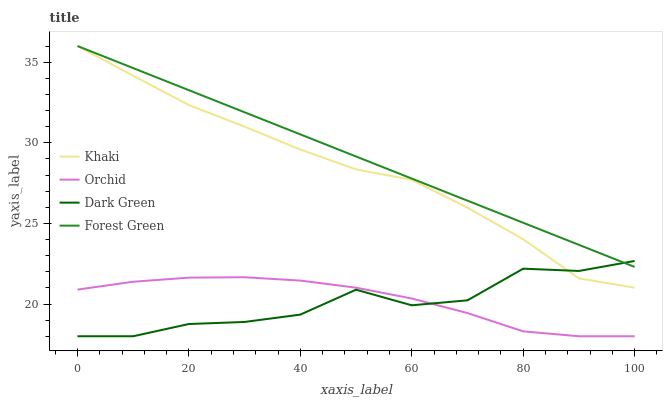Does Khaki have the minimum area under the curve?
Answer yes or no. No. Does Khaki have the maximum area under the curve?
Answer yes or no. No. Is Khaki the smoothest?
Answer yes or no. No. Is Khaki the roughest?
Answer yes or no. No. Does Khaki have the lowest value?
Answer yes or no. No. Does Dark Green have the highest value?
Answer yes or no. No. Is Orchid less than Forest Green?
Answer yes or no. Yes. Is Forest Green greater than Orchid?
Answer yes or no. Yes. Does Orchid intersect Forest Green?
Answer yes or no. No. 